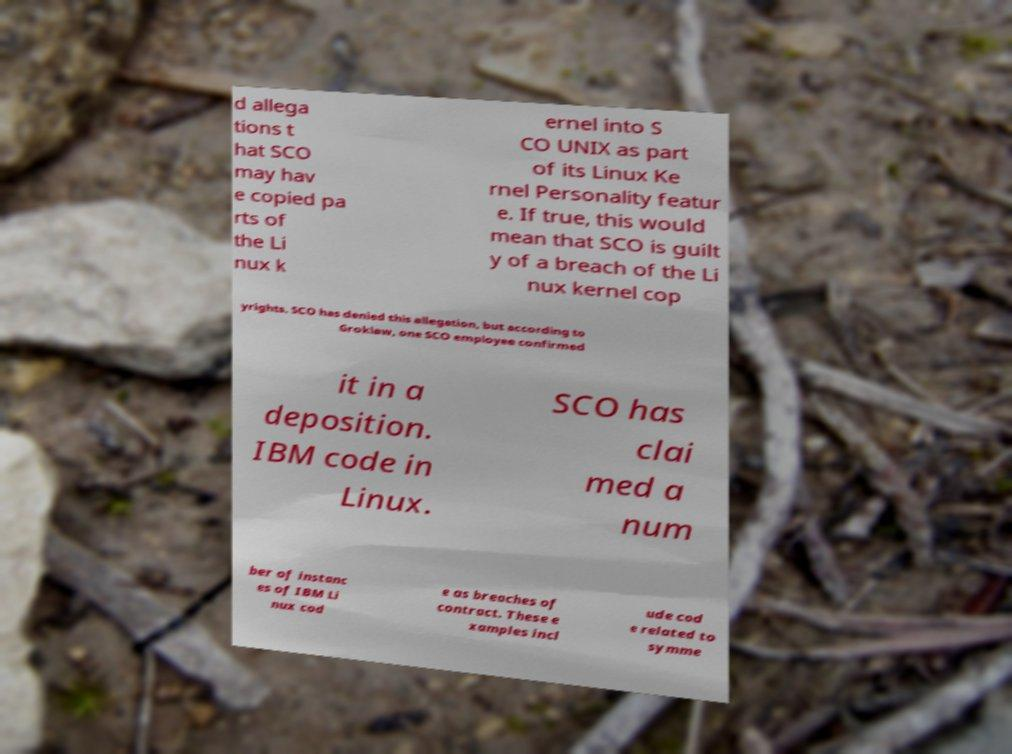Please read and relay the text visible in this image. What does it say? d allega tions t hat SCO may hav e copied pa rts of the Li nux k ernel into S CO UNIX as part of its Linux Ke rnel Personality featur e. If true, this would mean that SCO is guilt y of a breach of the Li nux kernel cop yrights. SCO has denied this allegation, but according to Groklaw, one SCO employee confirmed it in a deposition. IBM code in Linux. SCO has clai med a num ber of instanc es of IBM Li nux cod e as breaches of contract. These e xamples incl ude cod e related to symme 